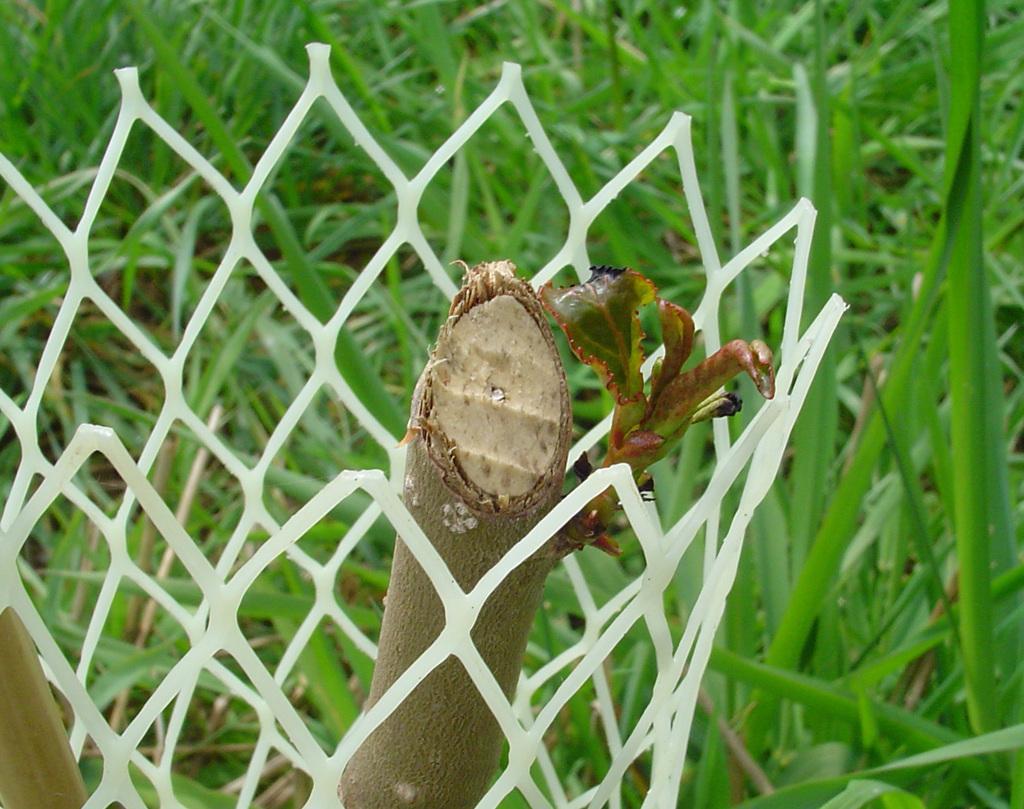In one or two sentences, can you explain what this image depicts? In the foreground of this image, it seems like a plant and there is fencing around it. In the background, there is grass. 